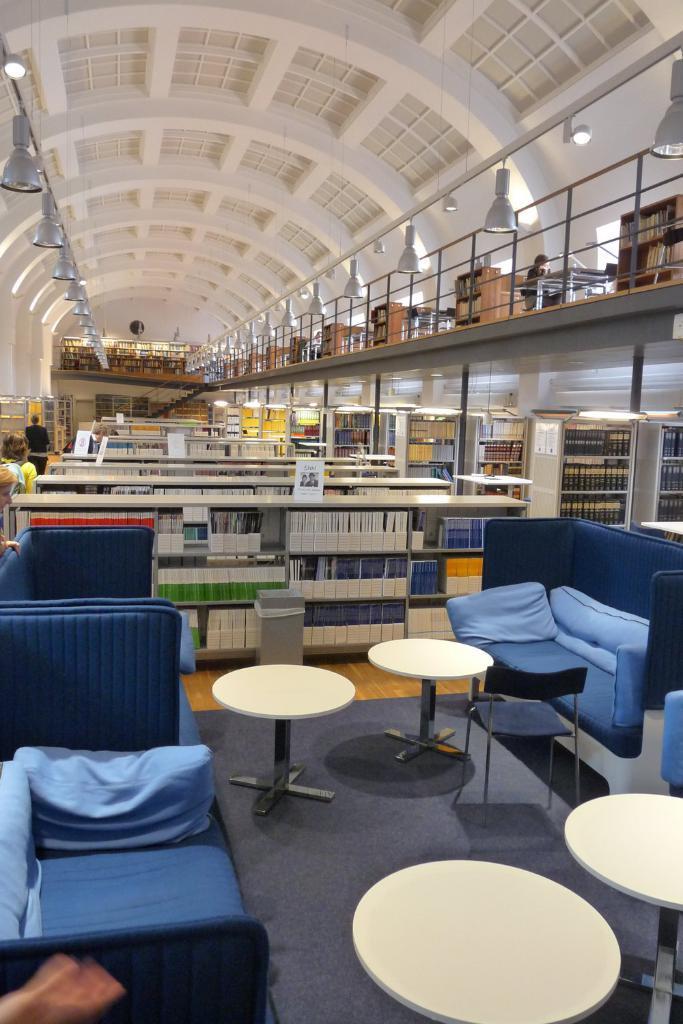Please provide a concise description of this image. There are blue sofas on either side and there are white tables in middle and there are many bookshelves in front of it. 